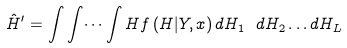Convert formula to latex. <formula><loc_0><loc_0><loc_500><loc_500>\hat { H } ^ { \prime } = \int \int \dots \int H f \left ( H | Y , x \right ) d H _ { 1 } \ d H _ { 2 } \dots d H _ { L }</formula> 